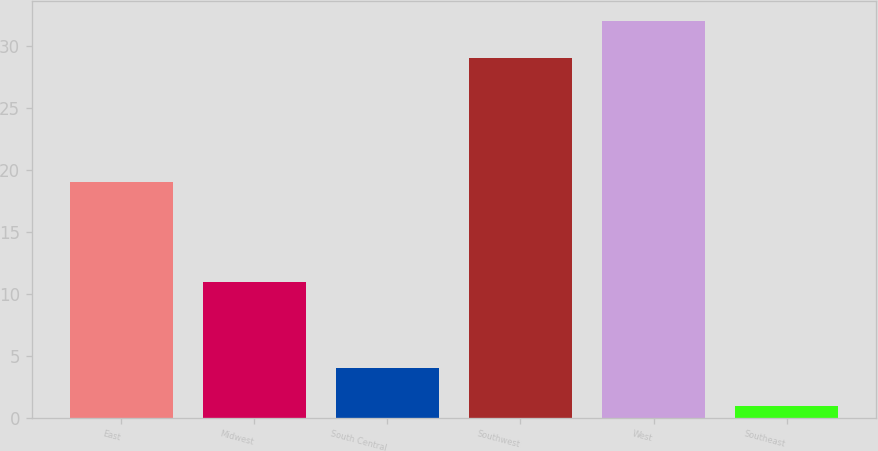Convert chart. <chart><loc_0><loc_0><loc_500><loc_500><bar_chart><fcel>East<fcel>Midwest<fcel>South Central<fcel>Southwest<fcel>West<fcel>Southeast<nl><fcel>19<fcel>11<fcel>4<fcel>29<fcel>32<fcel>1<nl></chart> 